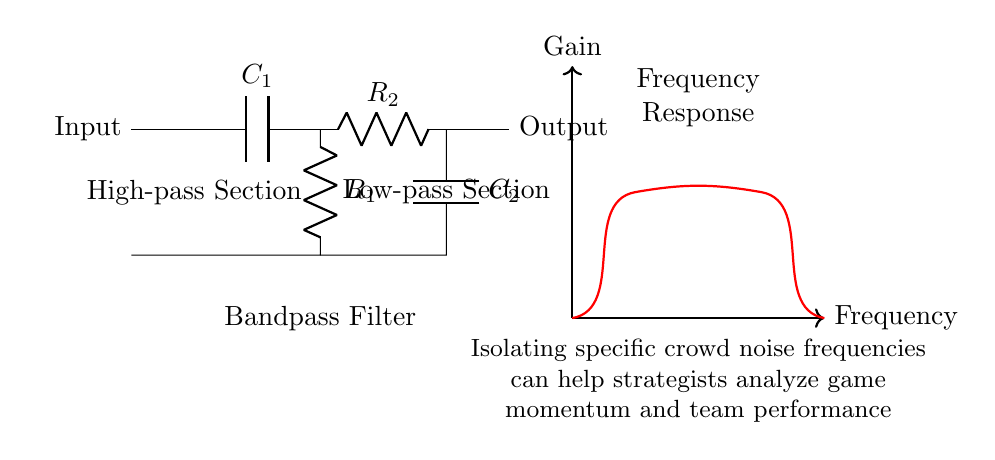What are the two types of filters in this circuit? The circuit has a high-pass filter section and a low-pass filter section, which are responsible for filtering different frequency ranges.
Answer: high-pass and low-pass What is the role of capacitors in this circuit? Capacitors in the high-pass and low-pass filter sections block certain frequencies while allowing others to pass, effectively shaping the frequency response of the filter.
Answer: Block certain frequencies Which component is in the high-pass filter section? The high-pass filter section includes the capacitor labeled C1 and the resistor labeled R1, which work together to filter out lower frequencies.
Answer: C1 and R1 What is the output of the filter related to? The output of the bandpass filter relates to isolating specific frequency ranges from noise, allowing for clearer analysis in applications like crowd noise cancellation.
Answer: Isolating specific frequency ranges What does the frequency response curve indicate? The frequency response curve indicates how the gain of the filter varies with different frequencies, showing which frequencies are amplified and which are attenuated.
Answer: Gain variation with frequency 